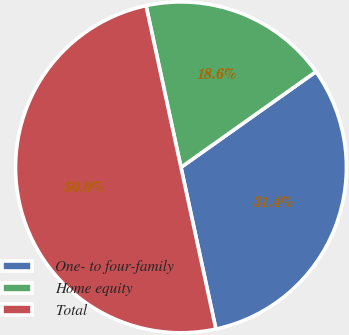Convert chart to OTSL. <chart><loc_0><loc_0><loc_500><loc_500><pie_chart><fcel>One- to four-family<fcel>Home equity<fcel>Total<nl><fcel>31.43%<fcel>18.57%<fcel>50.0%<nl></chart> 